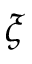<formula> <loc_0><loc_0><loc_500><loc_500>\xi</formula> 